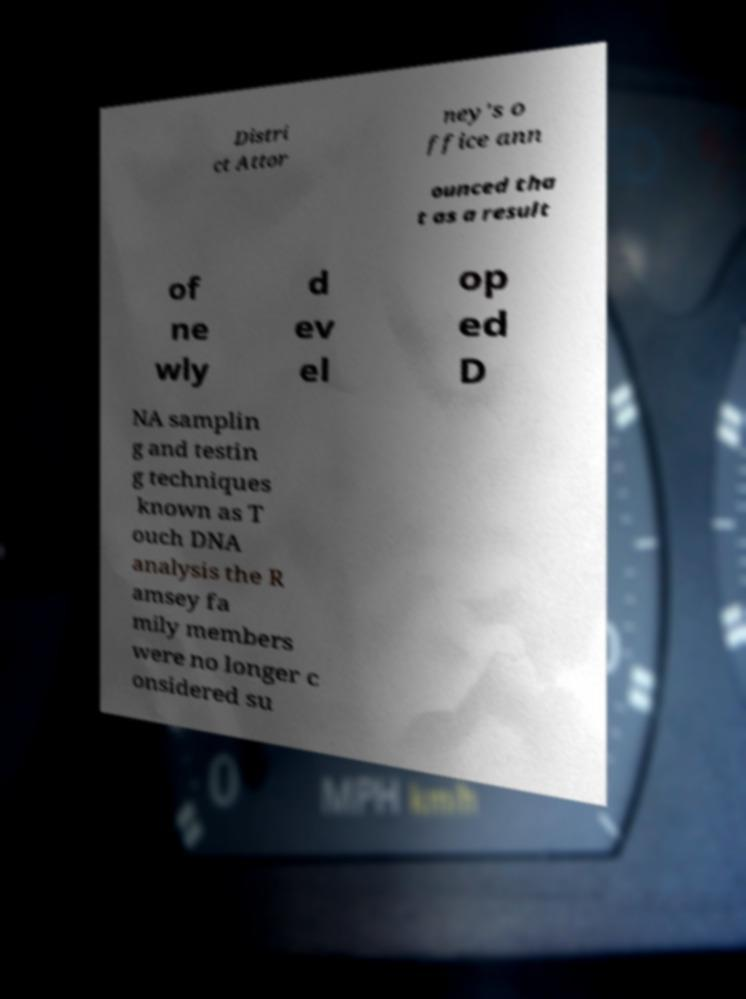For documentation purposes, I need the text within this image transcribed. Could you provide that? Distri ct Attor ney's o ffice ann ounced tha t as a result of ne wly d ev el op ed D NA samplin g and testin g techniques known as T ouch DNA analysis the R amsey fa mily members were no longer c onsidered su 